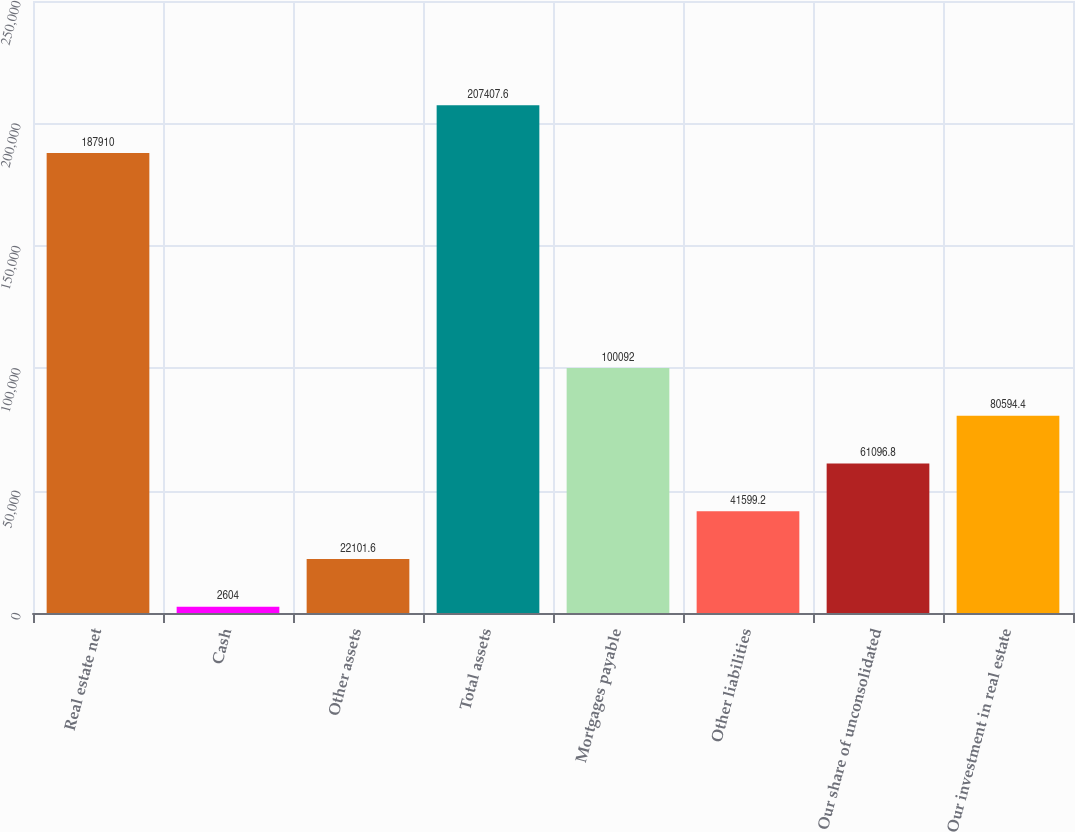Convert chart. <chart><loc_0><loc_0><loc_500><loc_500><bar_chart><fcel>Real estate net<fcel>Cash<fcel>Other assets<fcel>Total assets<fcel>Mortgages payable<fcel>Other liabilities<fcel>Our share of unconsolidated<fcel>Our investment in real estate<nl><fcel>187910<fcel>2604<fcel>22101.6<fcel>207408<fcel>100092<fcel>41599.2<fcel>61096.8<fcel>80594.4<nl></chart> 